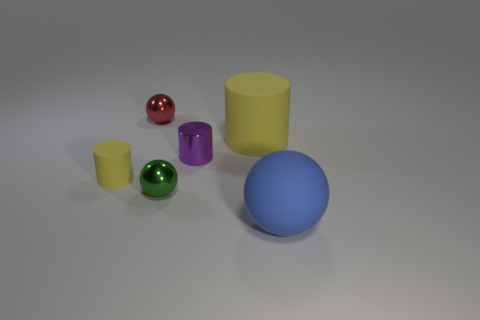Add 2 big rubber objects. How many objects exist? 8 Add 5 tiny red things. How many tiny red things are left? 6 Add 4 small purple cylinders. How many small purple cylinders exist? 5 Subtract 0 brown cylinders. How many objects are left? 6 Subtract all small red shiny cubes. Subtract all purple cylinders. How many objects are left? 5 